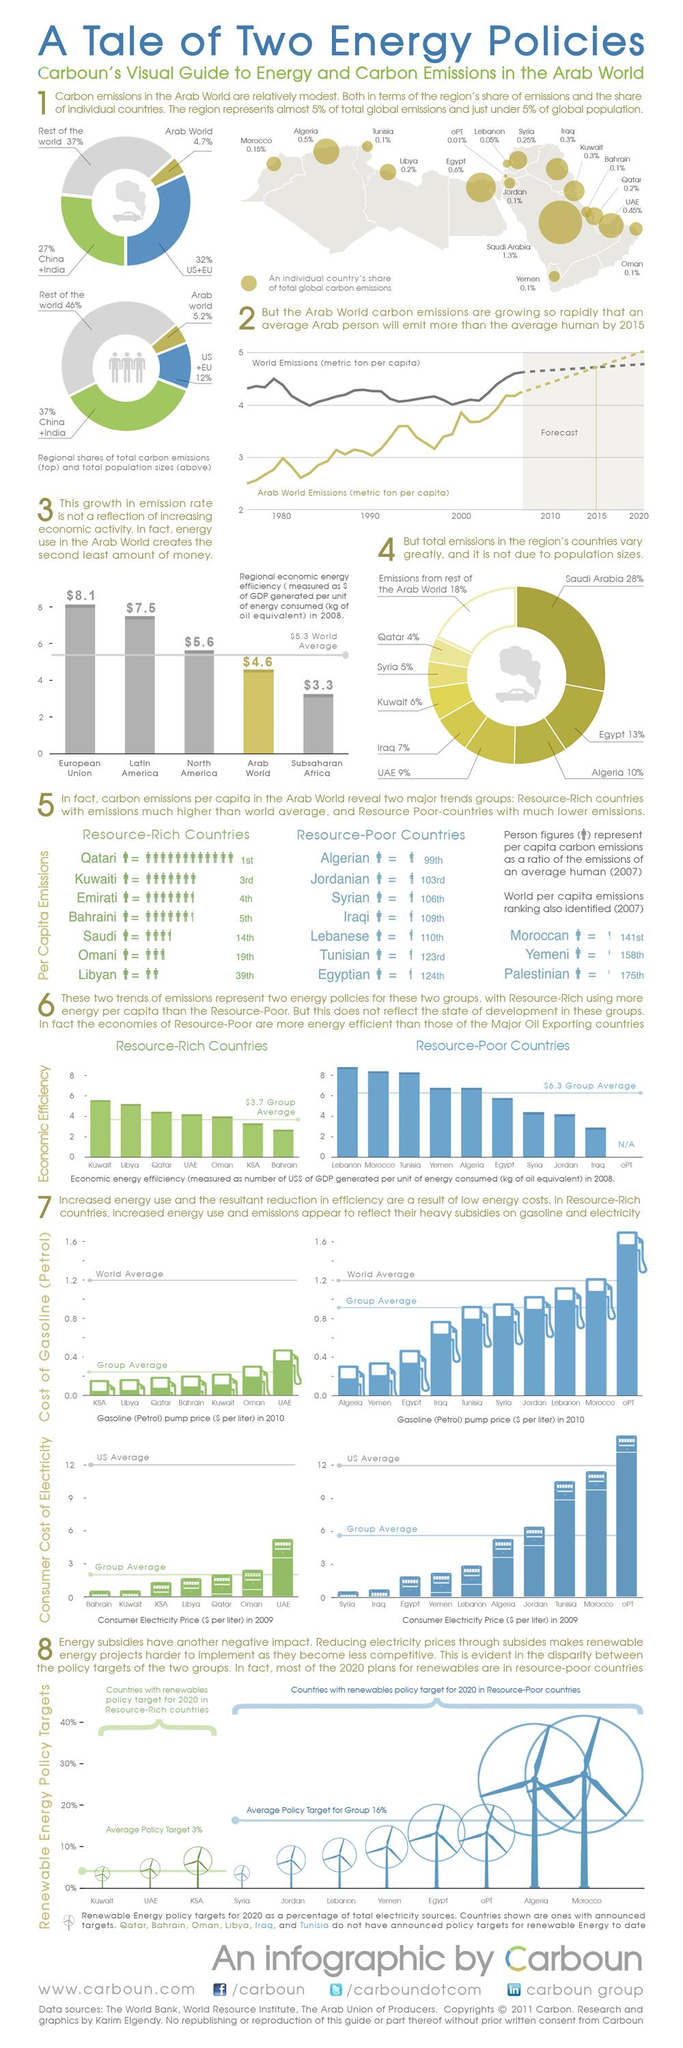List a handful of essential elements in this visual. Egypt, an Arab country, has the second-highest amount of global carbon emissions. The United States and the European Union are assigned the color code of blue in global carbon emissions, which is based on the Kyoto Protocol and the Paris Agreement. Tunisia, an Arab country with limited natural resources, has the third-highest electricity rate among all Arab countries. Oman, an Arab country with abundant natural resources, has the second-highest electricity rate among all Arab countries. Saudi Arabia is the Arab country with the highest global carbon emissions. 